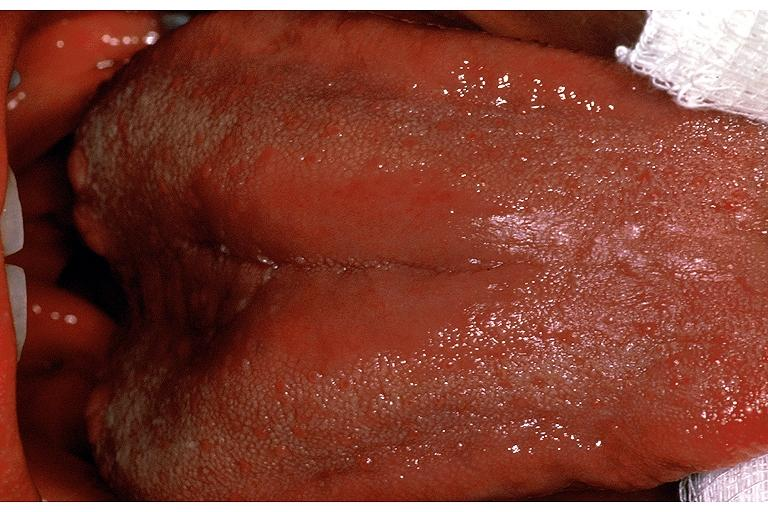what does this image show?
Answer the question using a single word or phrase. Median rhomboid glossitis 